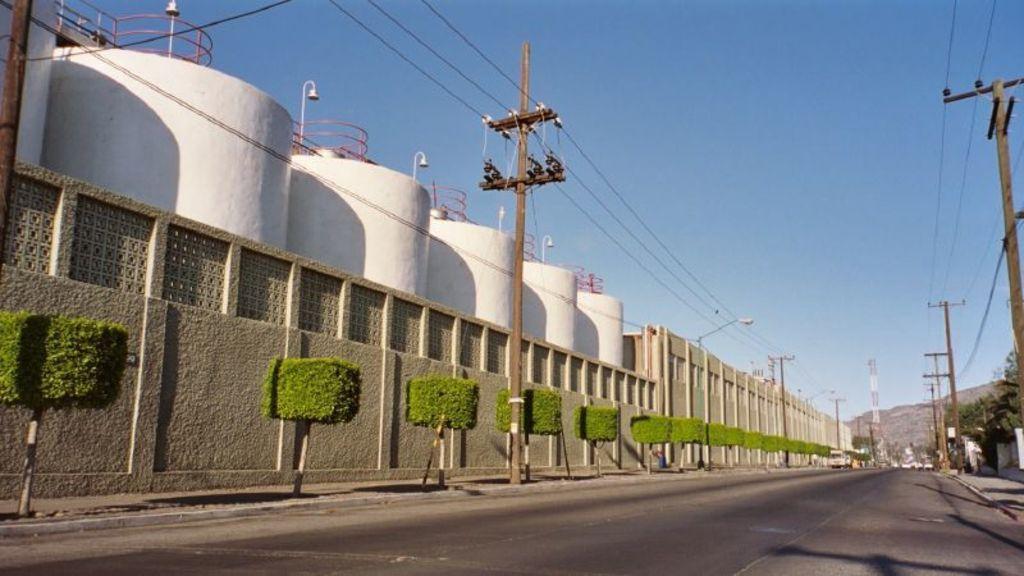In one or two sentences, can you explain what this image depicts? In this picture we can see a wall on the left side, there are some bushes, poles, wires and lights in the middle, on the right side there are some trees, we can see the sky at the top of the picture. 